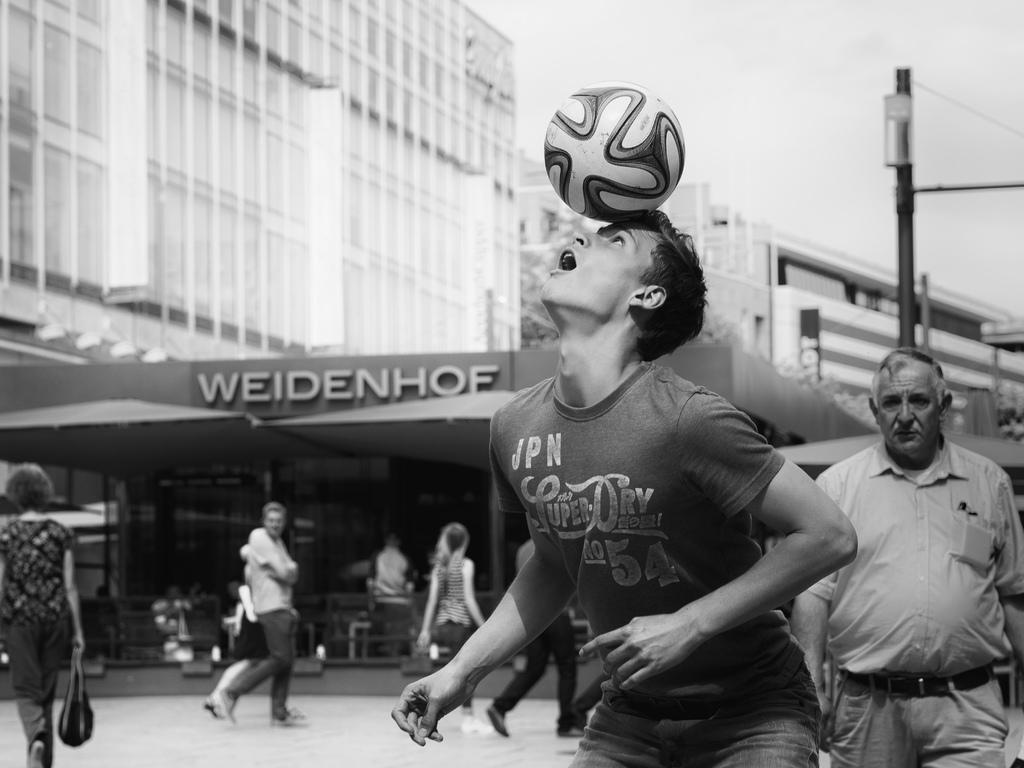Could you give a brief overview of what you see in this image? In the picture I can see people are walking on the ground among them the man in the front is holding a ball on his head. In the background I can see buildings, the sky, a pole and some other objects. This image is black and white in color. 